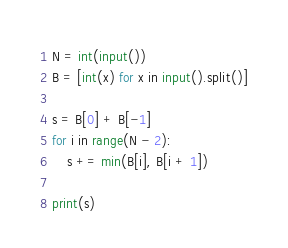<code> <loc_0><loc_0><loc_500><loc_500><_Python_>N = int(input())
B = [int(x) for x in input().split()]

s = B[0] + B[-1]
for i in range(N - 2):
    s += min(B[i], B[i + 1])

print(s)
</code> 